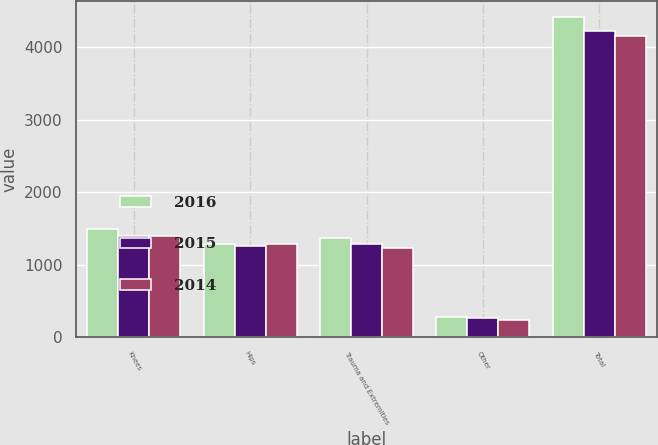Convert chart. <chart><loc_0><loc_0><loc_500><loc_500><stacked_bar_chart><ecel><fcel>Knees<fcel>Hips<fcel>Trauma and Extremities<fcel>Other<fcel>Total<nl><fcel>2016<fcel>1490<fcel>1283<fcel>1364<fcel>285<fcel>4422<nl><fcel>2015<fcel>1403<fcel>1263<fcel>1291<fcel>266<fcel>4223<nl><fcel>2014<fcel>1396<fcel>1291<fcel>1230<fcel>236<fcel>4153<nl></chart> 